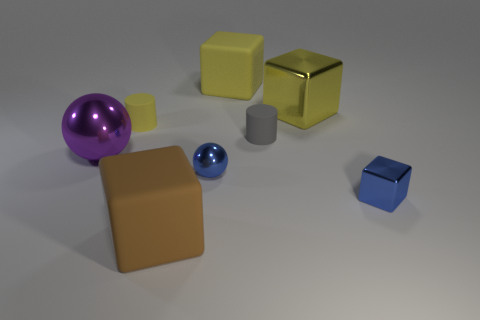How many tiny things are either purple balls or blue shiny objects?
Provide a succinct answer. 2. Are there any yellow shiny cylinders of the same size as the purple metal ball?
Make the answer very short. No. There is a object in front of the shiny cube in front of the tiny cylinder that is on the right side of the large yellow rubber cube; what color is it?
Keep it short and to the point. Brown. Do the purple ball and the small object that is on the left side of the big brown rubber block have the same material?
Make the answer very short. No. There is another thing that is the same shape as the tiny gray thing; what is its size?
Offer a terse response. Small. Are there the same number of blue metallic cubes that are in front of the big yellow matte thing and small cylinders to the right of the yellow metallic block?
Keep it short and to the point. No. Are there an equal number of brown rubber things on the left side of the yellow cylinder and big purple things?
Your response must be concise. No. Do the brown rubber thing and the blue metallic thing to the left of the gray rubber cylinder have the same size?
Your answer should be very brief. No. There is a blue thing left of the gray cylinder; what is its shape?
Your answer should be very brief. Sphere. Are there any other things that have the same shape as the small yellow object?
Offer a terse response. Yes. 